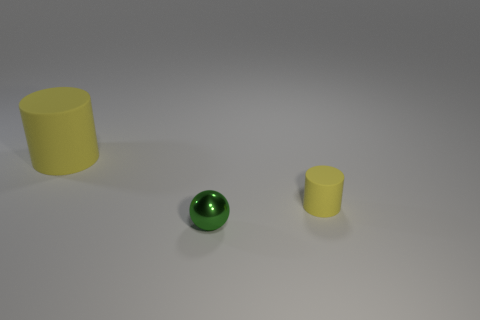How many things are tiny cyan metallic blocks or big yellow objects?
Give a very brief answer. 1. There is a yellow thing that is to the left of the tiny object in front of the small yellow object; how big is it?
Your answer should be compact. Large. What is the shape of the object that is to the left of the tiny yellow rubber thing and on the right side of the large rubber object?
Your response must be concise. Sphere. What is the color of the tiny rubber object that is the same shape as the large yellow rubber object?
Provide a short and direct response. Yellow. How many things are either things that are behind the small yellow cylinder or cylinders right of the tiny green shiny ball?
Make the answer very short. 2. What is the shape of the tiny green metallic object?
Ensure brevity in your answer.  Sphere. The small matte thing that is the same color as the large cylinder is what shape?
Your answer should be compact. Cylinder. What number of other objects have the same material as the tiny yellow object?
Your answer should be very brief. 1. The large matte thing has what color?
Your answer should be very brief. Yellow. There is a object that is the same size as the ball; what color is it?
Offer a terse response. Yellow. 